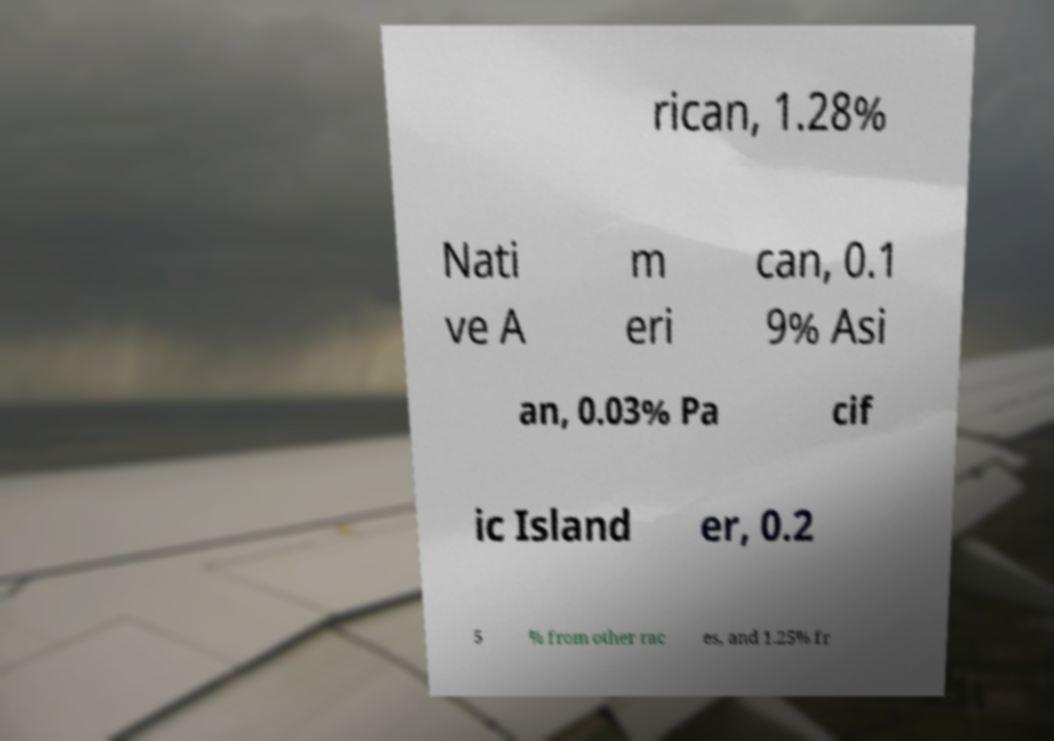Could you assist in decoding the text presented in this image and type it out clearly? rican, 1.28% Nati ve A m eri can, 0.1 9% Asi an, 0.03% Pa cif ic Island er, 0.2 5 % from other rac es, and 1.25% fr 